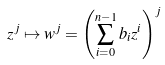Convert formula to latex. <formula><loc_0><loc_0><loc_500><loc_500>z ^ { j } \mapsto w ^ { j } = \left ( \sum _ { i = 0 } ^ { n - 1 } b _ { i } z ^ { i } \right ) ^ { j }</formula> 